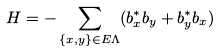<formula> <loc_0><loc_0><loc_500><loc_500>H = - \sum _ { \{ x , y \} \in E \Lambda } ( b ^ { * } _ { x } b _ { y } + b ^ { * } _ { y } b _ { x } )</formula> 